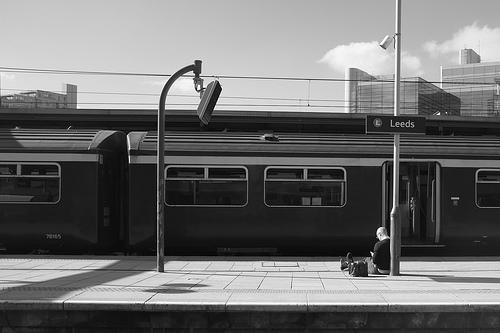Question: what type of photo is this?
Choices:
A. Black and white.
B. Color.
C. Digital.
D. Film.
Answer with the letter. Answer: A Question: when is this taken?
Choices:
A. At night.
B. During the day.
C. At dawn.
D. At dusk.
Answer with the letter. Answer: B Question: what does the sign say?
Choices:
A. London.
B. Nottingham.
C. Leeds.
D. Chelsea.
Answer with the letter. Answer: C Question: who else can be seen?
Choices:
A. One person.
B. No one.
C. Two people.
D. Three people.
Answer with the letter. Answer: B Question: why is he siting?
Choices:
A. He's resting.
B. He is thinking.
C. He's relaxing.
D. He is sleeping.
Answer with the letter. Answer: C Question: what is in the background?
Choices:
A. Buildings.
B. Trees.
C. People.
D. Dogs.
Answer with the letter. Answer: A 